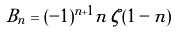<formula> <loc_0><loc_0><loc_500><loc_500>B _ { n } = ( - 1 ) ^ { n + 1 } n \, \zeta ( 1 - n )</formula> 